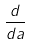<formula> <loc_0><loc_0><loc_500><loc_500>\frac { d } { d a }</formula> 